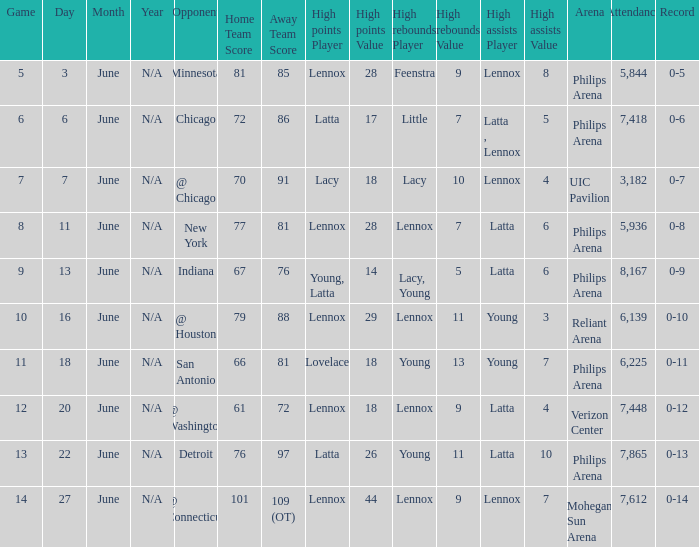Who contributed the most assists in the game where the final score was 79-88? Young (3). 